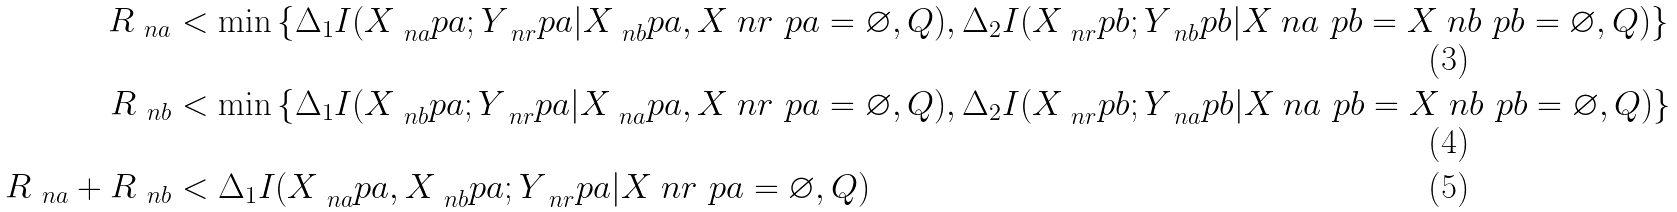Convert formula to latex. <formula><loc_0><loc_0><loc_500><loc_500>R _ { \ n a } & < \min \left \{ \Delta _ { 1 } I ( X _ { \ n a } ^ { \ } p a ; Y _ { \ n r } ^ { \ } p a | X _ { \ n b } ^ { \ } p a , X _ { \ } n r ^ { \ } p a = \varnothing , Q ) , \Delta _ { 2 } I ( X _ { \ n r } ^ { \ } p b ; Y _ { \ n b } ^ { \ } p b | X _ { \ } n a ^ { \ } p b = X _ { \ } n b ^ { \ } p b = \varnothing , Q ) \right \} \\ R _ { \ n b } & < \min \left \{ \Delta _ { 1 } I ( X _ { \ n b } ^ { \ } p a ; Y _ { \ n r } ^ { \ } p a | X _ { \ n a } ^ { \ } p a , X _ { \ } n r ^ { \ } p a = \varnothing , Q ) , \Delta _ { 2 } I ( X _ { \ n r } ^ { \ } p b ; Y _ { \ n a } ^ { \ } p b | X _ { \ } n a ^ { \ } p b = X _ { \ } n b ^ { \ } p b = \varnothing , Q ) \right \} \\ R _ { \ n a } + R _ { \ n b } & < \Delta _ { 1 } I ( X _ { \ n a } ^ { \ } p a , X _ { \ n b } ^ { \ } p a ; Y _ { \ n r } ^ { \ } p a | X _ { \ } n r ^ { \ } p a = \varnothing , Q )</formula> 